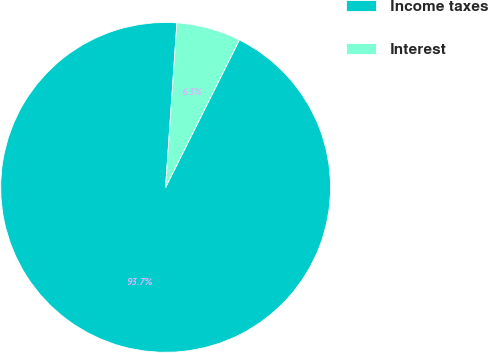Convert chart. <chart><loc_0><loc_0><loc_500><loc_500><pie_chart><fcel>Income taxes<fcel>Interest<nl><fcel>93.71%<fcel>6.29%<nl></chart> 